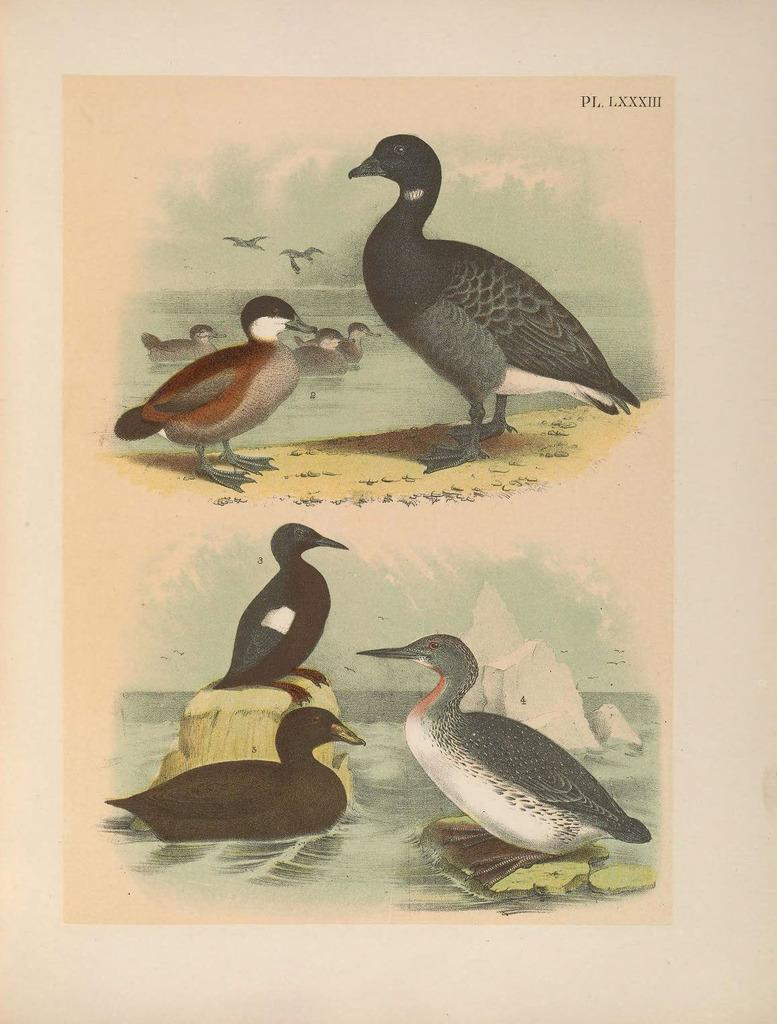What is depicted on the paper in the image? There are printed images of ducks on the paper. What is the primary element visible in the image? Water is visible in the image. What other objects can be seen in the image? There are rocks and birds flying in the image. Where is the text located in the image? The text is at the top right corner of the picture. What type of shoe can be seen floating in the water in the image? There is no shoe present in the image; it only features printed images of ducks on paper, water, rocks, and flying birds. 